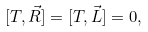<formula> <loc_0><loc_0><loc_500><loc_500>[ T , \vec { R } ] = [ T , \vec { L } ] = 0 ,</formula> 